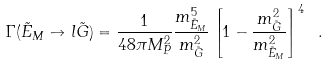<formula> <loc_0><loc_0><loc_500><loc_500>\Gamma ( \tilde { E } _ { M } \to l \tilde { G } ) = \frac { 1 } { 4 8 \pi M _ { P } ^ { 2 } } \frac { m _ { \tilde { E } _ { M } } ^ { 5 } } { m _ { \tilde { G } } ^ { 2 } } \left [ 1 - \frac { m _ { \tilde { G } } ^ { 2 } } { m _ { \tilde { E } _ { M } } ^ { 2 } } \right ] ^ { 4 } \ .</formula> 